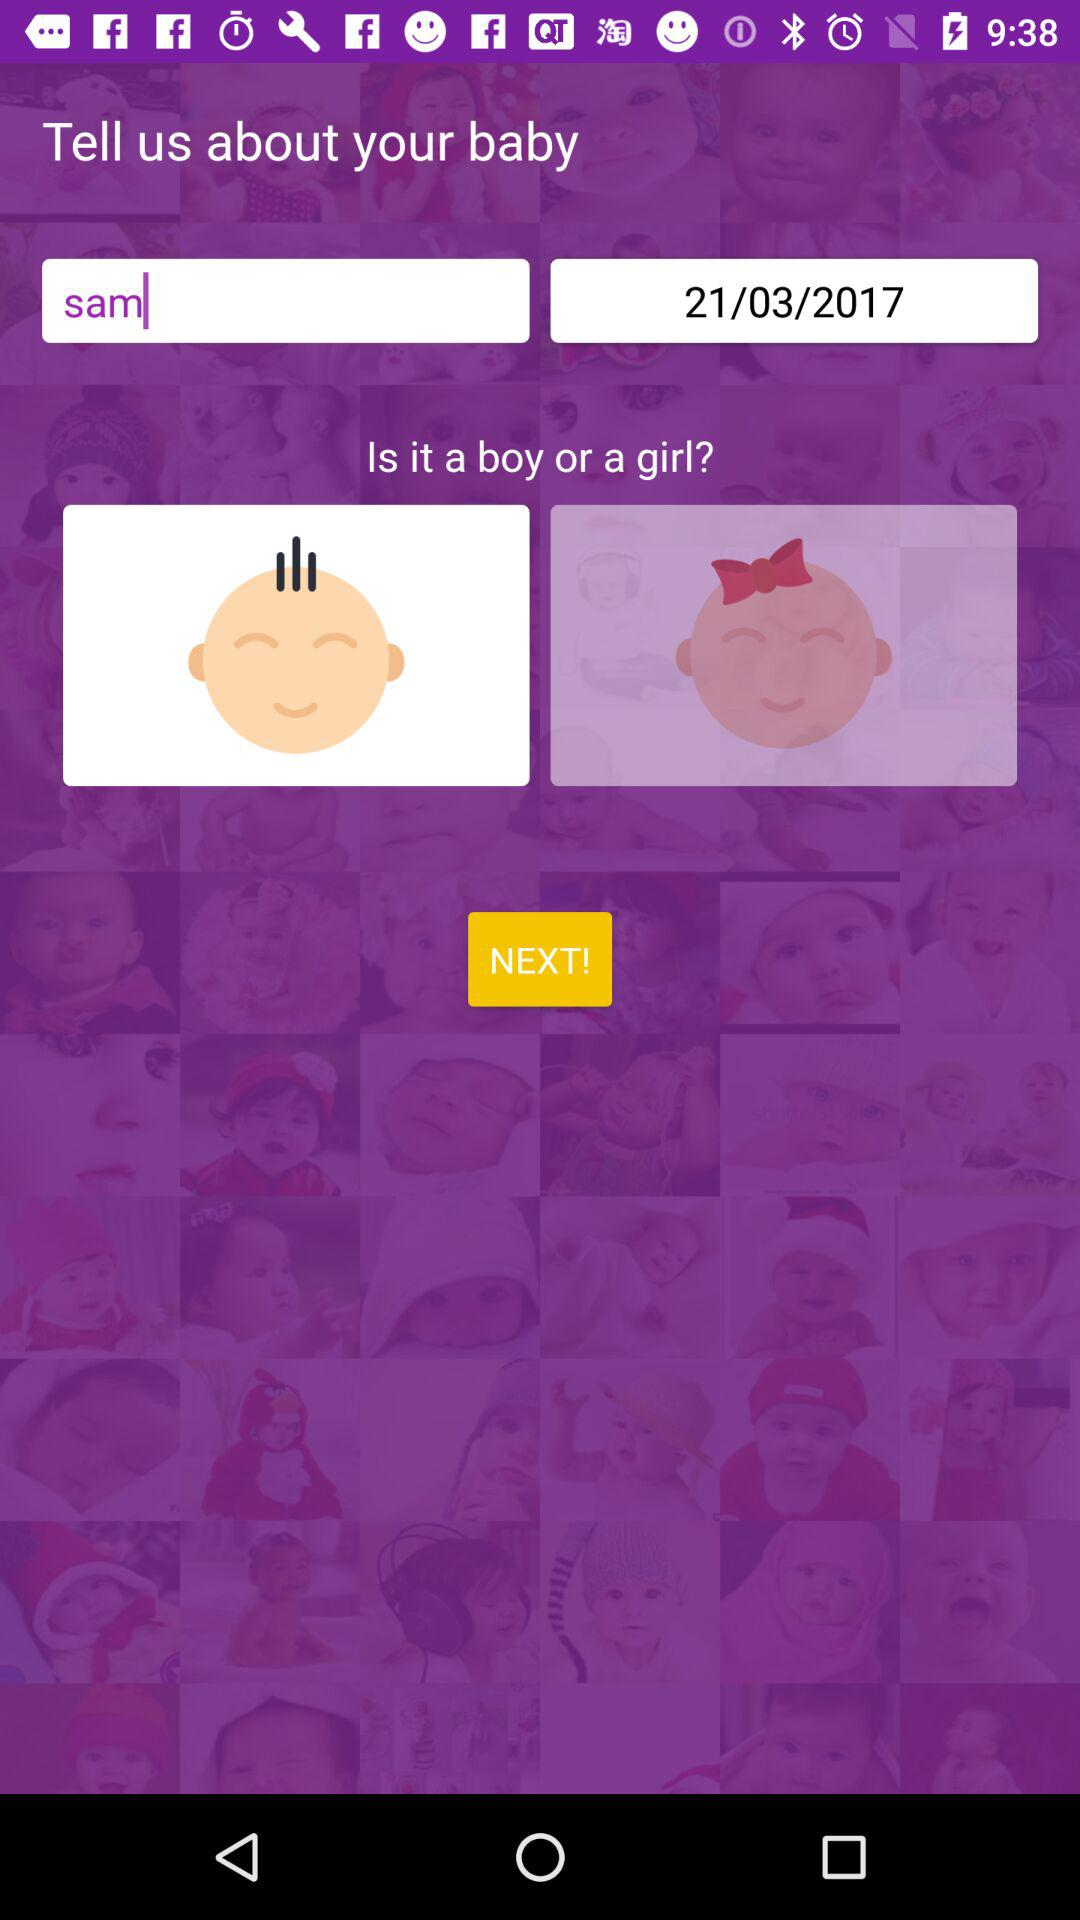Which gender is selected? The selected gender is boy. 